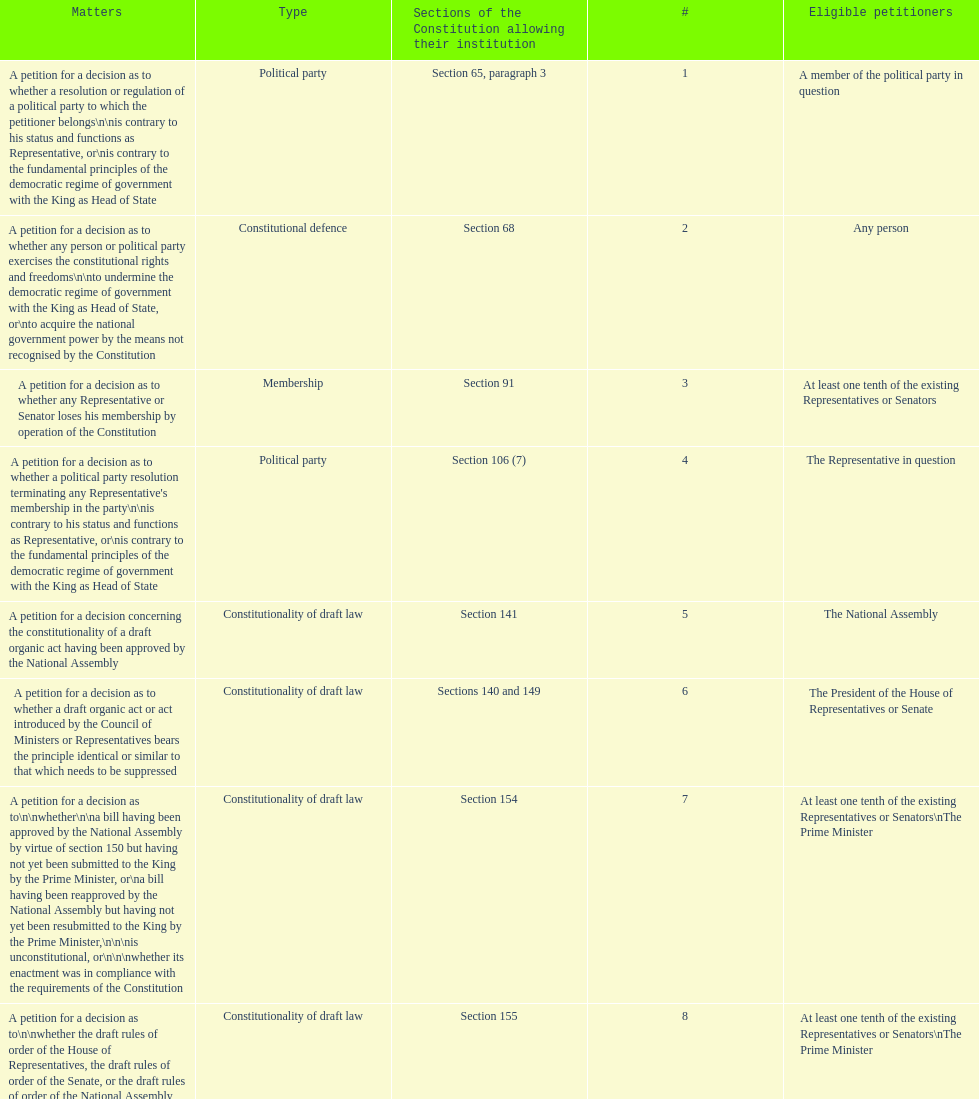Any person can petition matters 2 and 17. true or false? True. 